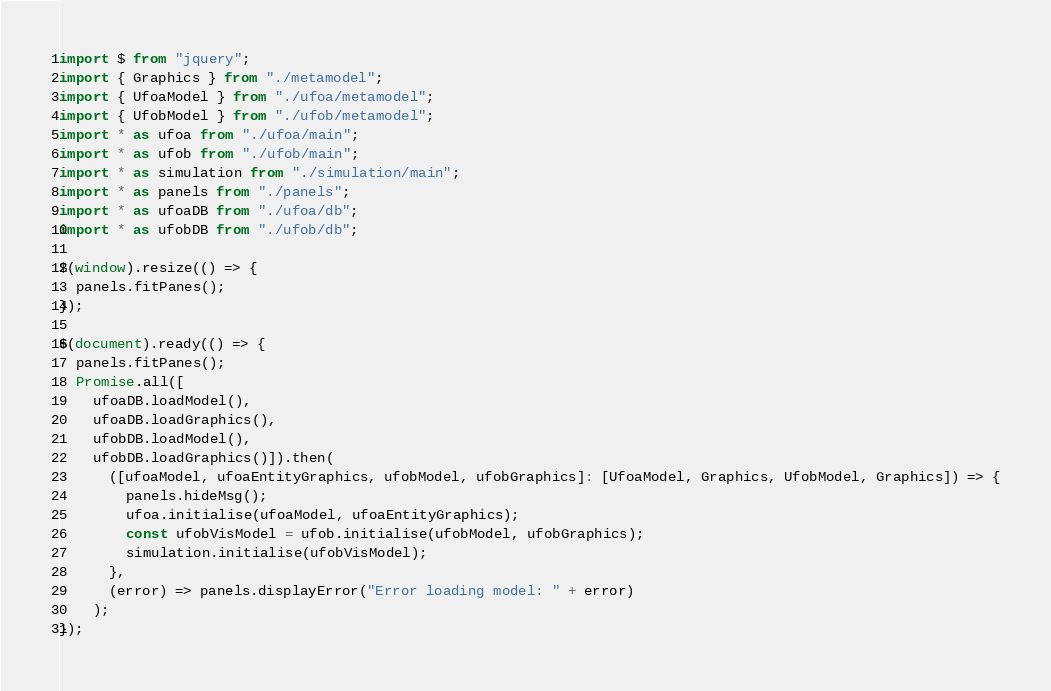Convert code to text. <code><loc_0><loc_0><loc_500><loc_500><_TypeScript_>import $ from "jquery";
import { Graphics } from "./metamodel";
import { UfoaModel } from "./ufoa/metamodel";
import { UfobModel } from "./ufob/metamodel";
import * as ufoa from "./ufoa/main";
import * as ufob from "./ufob/main";
import * as simulation from "./simulation/main";
import * as panels from "./panels";
import * as ufoaDB from "./ufoa/db";
import * as ufobDB from "./ufob/db";

$(window).resize(() => {
  panels.fitPanes();
});

$(document).ready(() => {
  panels.fitPanes();
  Promise.all([
    ufoaDB.loadModel(),
    ufoaDB.loadGraphics(),
    ufobDB.loadModel(),
    ufobDB.loadGraphics()]).then(
      ([ufoaModel, ufoaEntityGraphics, ufobModel, ufobGraphics]: [UfoaModel, Graphics, UfobModel, Graphics]) => {
        panels.hideMsg();
        ufoa.initialise(ufoaModel, ufoaEntityGraphics);
        const ufobVisModel = ufob.initialise(ufobModel, ufobGraphics);
        simulation.initialise(ufobVisModel);
      },
      (error) => panels.displayError("Error loading model: " + error)
    );
});
</code> 